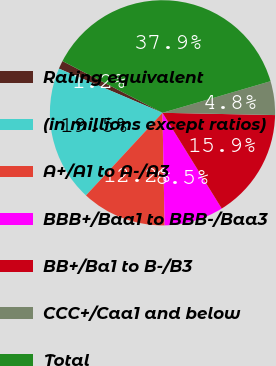<chart> <loc_0><loc_0><loc_500><loc_500><pie_chart><fcel>Rating equivalent<fcel>(in millions except ratios)<fcel>A+/A1 to A-/A3<fcel>BBB+/Baa1 to BBB-/Baa3<fcel>BB+/Ba1 to B-/B3<fcel>CCC+/Caa1 and below<fcel>Total<nl><fcel>1.18%<fcel>19.53%<fcel>12.19%<fcel>8.52%<fcel>15.86%<fcel>4.85%<fcel>37.88%<nl></chart> 